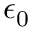<formula> <loc_0><loc_0><loc_500><loc_500>\epsilon _ { 0 }</formula> 